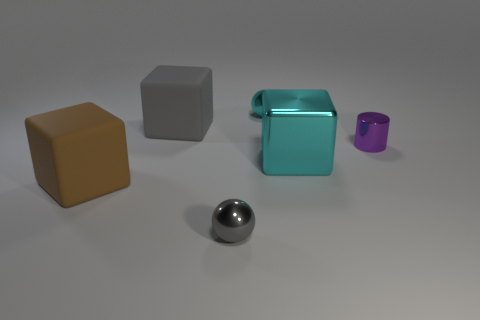What shape is the tiny gray object?
Offer a very short reply. Sphere. What size is the gray thing that is left of the ball in front of the gray thing behind the large brown matte object?
Your answer should be compact. Large. What number of other things are the same shape as the big gray rubber thing?
Provide a succinct answer. 2. Is the shape of the gray object in front of the large brown matte block the same as the large rubber object that is on the right side of the big brown thing?
Make the answer very short. No. How many blocks are either big rubber things or blue things?
Make the answer very short. 2. What material is the gray thing that is behind the cube on the right side of the small object in front of the brown block?
Offer a terse response. Rubber. What number of other things are the same size as the gray metallic sphere?
Keep it short and to the point. 2. The sphere that is the same color as the big shiny object is what size?
Your answer should be compact. Small. Are there more large brown rubber blocks that are behind the purple cylinder than tiny cyan shiny balls?
Offer a terse response. No. Is there a shiny block that has the same color as the small cylinder?
Provide a short and direct response. No. 